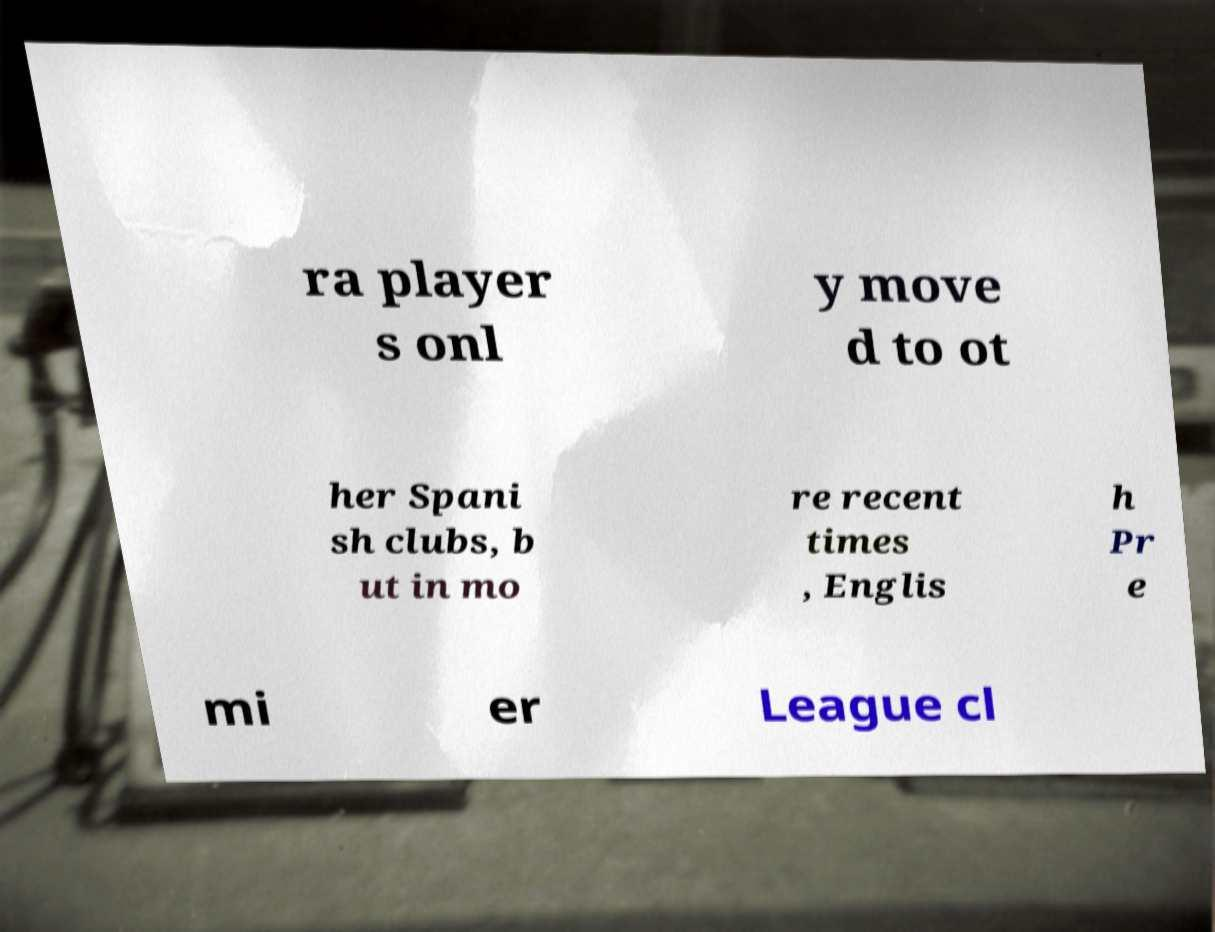Please identify and transcribe the text found in this image. ra player s onl y move d to ot her Spani sh clubs, b ut in mo re recent times , Englis h Pr e mi er League cl 